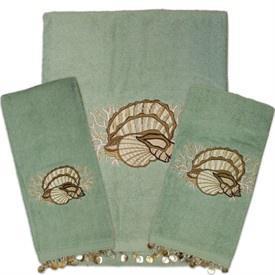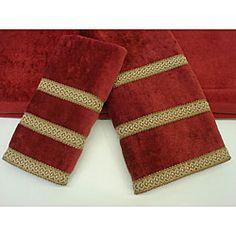The first image is the image on the left, the second image is the image on the right. Examine the images to the left and right. Is the description "The linens in the image on the right are red" accurate? Answer yes or no. Yes. 